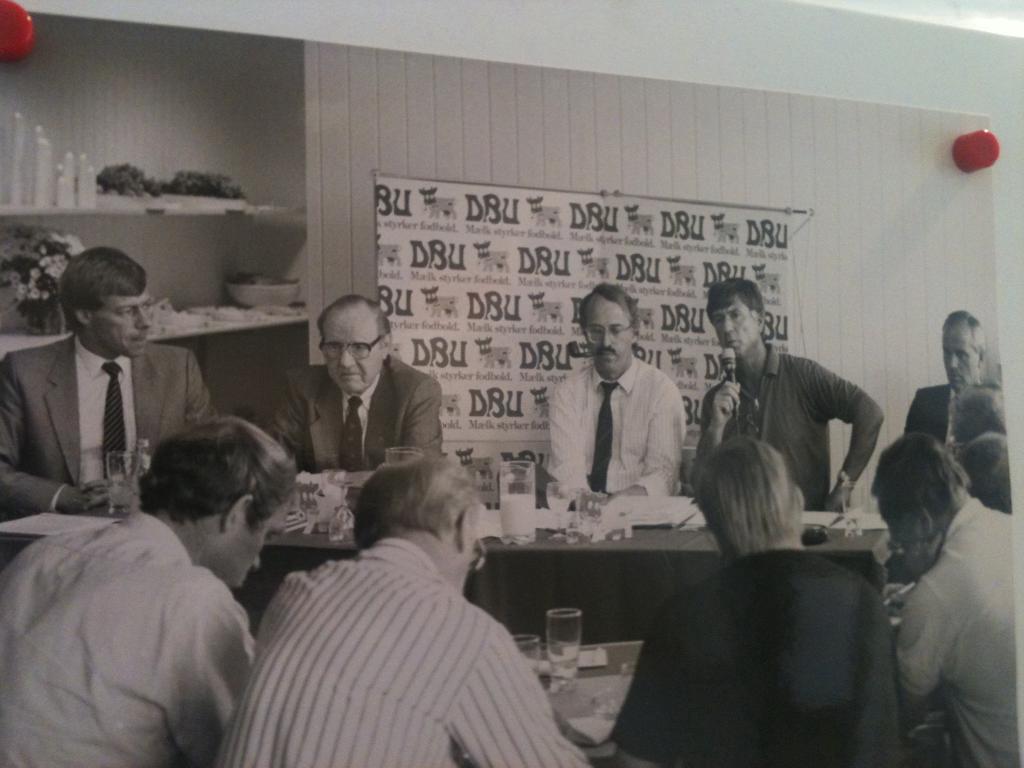Could you give a brief overview of what you see in this image? There are some members standing in front of a table on which some glasses, papers were placed. Some of them was sitting in front of them in the chairs. In the background there is a poster attached to the wall and a cup board. 